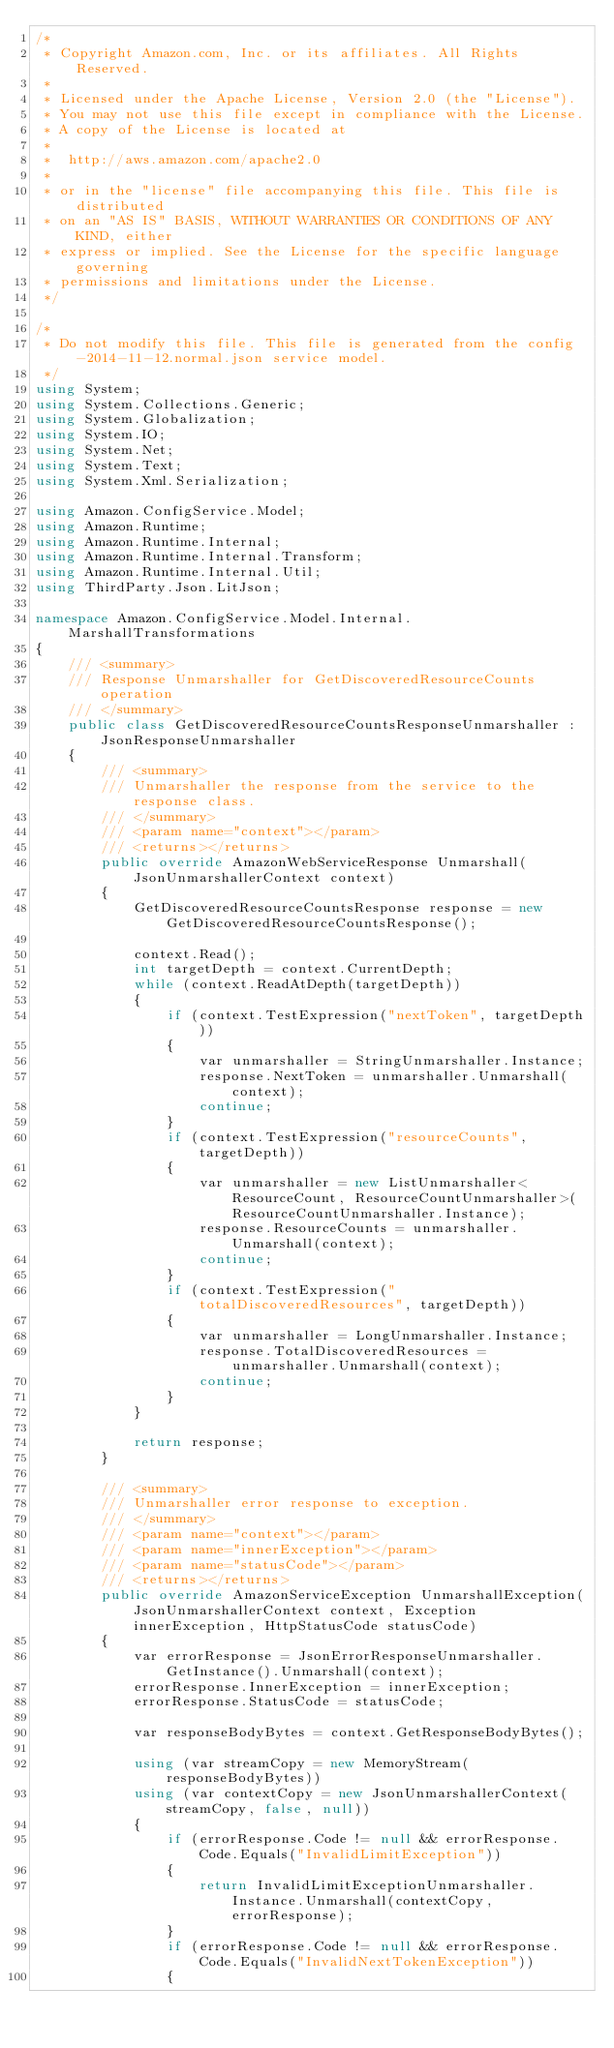Convert code to text. <code><loc_0><loc_0><loc_500><loc_500><_C#_>/*
 * Copyright Amazon.com, Inc. or its affiliates. All Rights Reserved.
 * 
 * Licensed under the Apache License, Version 2.0 (the "License").
 * You may not use this file except in compliance with the License.
 * A copy of the License is located at
 * 
 *  http://aws.amazon.com/apache2.0
 * 
 * or in the "license" file accompanying this file. This file is distributed
 * on an "AS IS" BASIS, WITHOUT WARRANTIES OR CONDITIONS OF ANY KIND, either
 * express or implied. See the License for the specific language governing
 * permissions and limitations under the License.
 */

/*
 * Do not modify this file. This file is generated from the config-2014-11-12.normal.json service model.
 */
using System;
using System.Collections.Generic;
using System.Globalization;
using System.IO;
using System.Net;
using System.Text;
using System.Xml.Serialization;

using Amazon.ConfigService.Model;
using Amazon.Runtime;
using Amazon.Runtime.Internal;
using Amazon.Runtime.Internal.Transform;
using Amazon.Runtime.Internal.Util;
using ThirdParty.Json.LitJson;

namespace Amazon.ConfigService.Model.Internal.MarshallTransformations
{
    /// <summary>
    /// Response Unmarshaller for GetDiscoveredResourceCounts operation
    /// </summary>  
    public class GetDiscoveredResourceCountsResponseUnmarshaller : JsonResponseUnmarshaller
    {
        /// <summary>
        /// Unmarshaller the response from the service to the response class.
        /// </summary>  
        /// <param name="context"></param>
        /// <returns></returns>
        public override AmazonWebServiceResponse Unmarshall(JsonUnmarshallerContext context)
        {
            GetDiscoveredResourceCountsResponse response = new GetDiscoveredResourceCountsResponse();

            context.Read();
            int targetDepth = context.CurrentDepth;
            while (context.ReadAtDepth(targetDepth))
            {
                if (context.TestExpression("nextToken", targetDepth))
                {
                    var unmarshaller = StringUnmarshaller.Instance;
                    response.NextToken = unmarshaller.Unmarshall(context);
                    continue;
                }
                if (context.TestExpression("resourceCounts", targetDepth))
                {
                    var unmarshaller = new ListUnmarshaller<ResourceCount, ResourceCountUnmarshaller>(ResourceCountUnmarshaller.Instance);
                    response.ResourceCounts = unmarshaller.Unmarshall(context);
                    continue;
                }
                if (context.TestExpression("totalDiscoveredResources", targetDepth))
                {
                    var unmarshaller = LongUnmarshaller.Instance;
                    response.TotalDiscoveredResources = unmarshaller.Unmarshall(context);
                    continue;
                }
            }

            return response;
        }

        /// <summary>
        /// Unmarshaller error response to exception.
        /// </summary>  
        /// <param name="context"></param>
        /// <param name="innerException"></param>
        /// <param name="statusCode"></param>
        /// <returns></returns>
        public override AmazonServiceException UnmarshallException(JsonUnmarshallerContext context, Exception innerException, HttpStatusCode statusCode)
        {
            var errorResponse = JsonErrorResponseUnmarshaller.GetInstance().Unmarshall(context);
            errorResponse.InnerException = innerException;
            errorResponse.StatusCode = statusCode;

            var responseBodyBytes = context.GetResponseBodyBytes();

            using (var streamCopy = new MemoryStream(responseBodyBytes))
            using (var contextCopy = new JsonUnmarshallerContext(streamCopy, false, null))
            {
                if (errorResponse.Code != null && errorResponse.Code.Equals("InvalidLimitException"))
                {
                    return InvalidLimitExceptionUnmarshaller.Instance.Unmarshall(contextCopy, errorResponse);
                }
                if (errorResponse.Code != null && errorResponse.Code.Equals("InvalidNextTokenException"))
                {</code> 